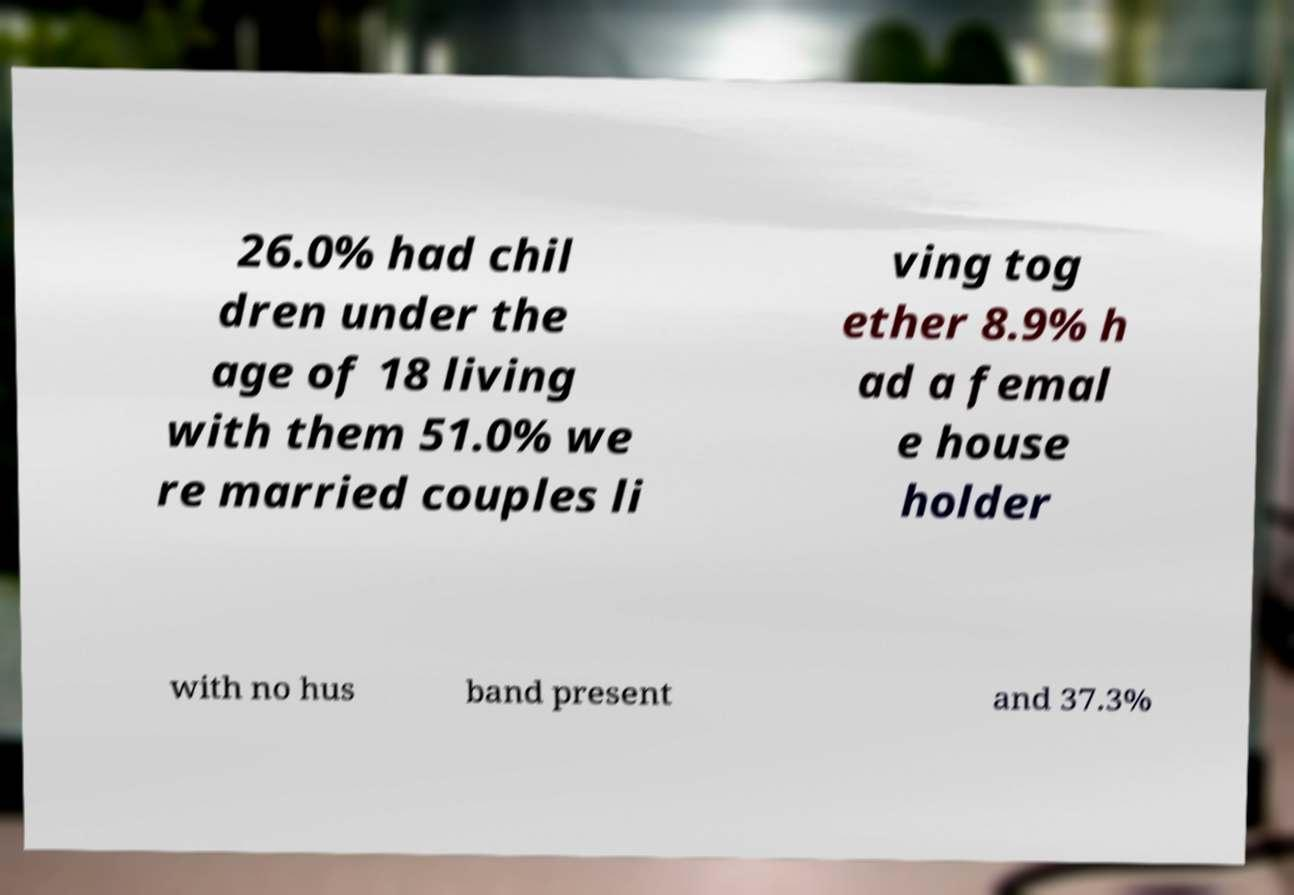I need the written content from this picture converted into text. Can you do that? 26.0% had chil dren under the age of 18 living with them 51.0% we re married couples li ving tog ether 8.9% h ad a femal e house holder with no hus band present and 37.3% 